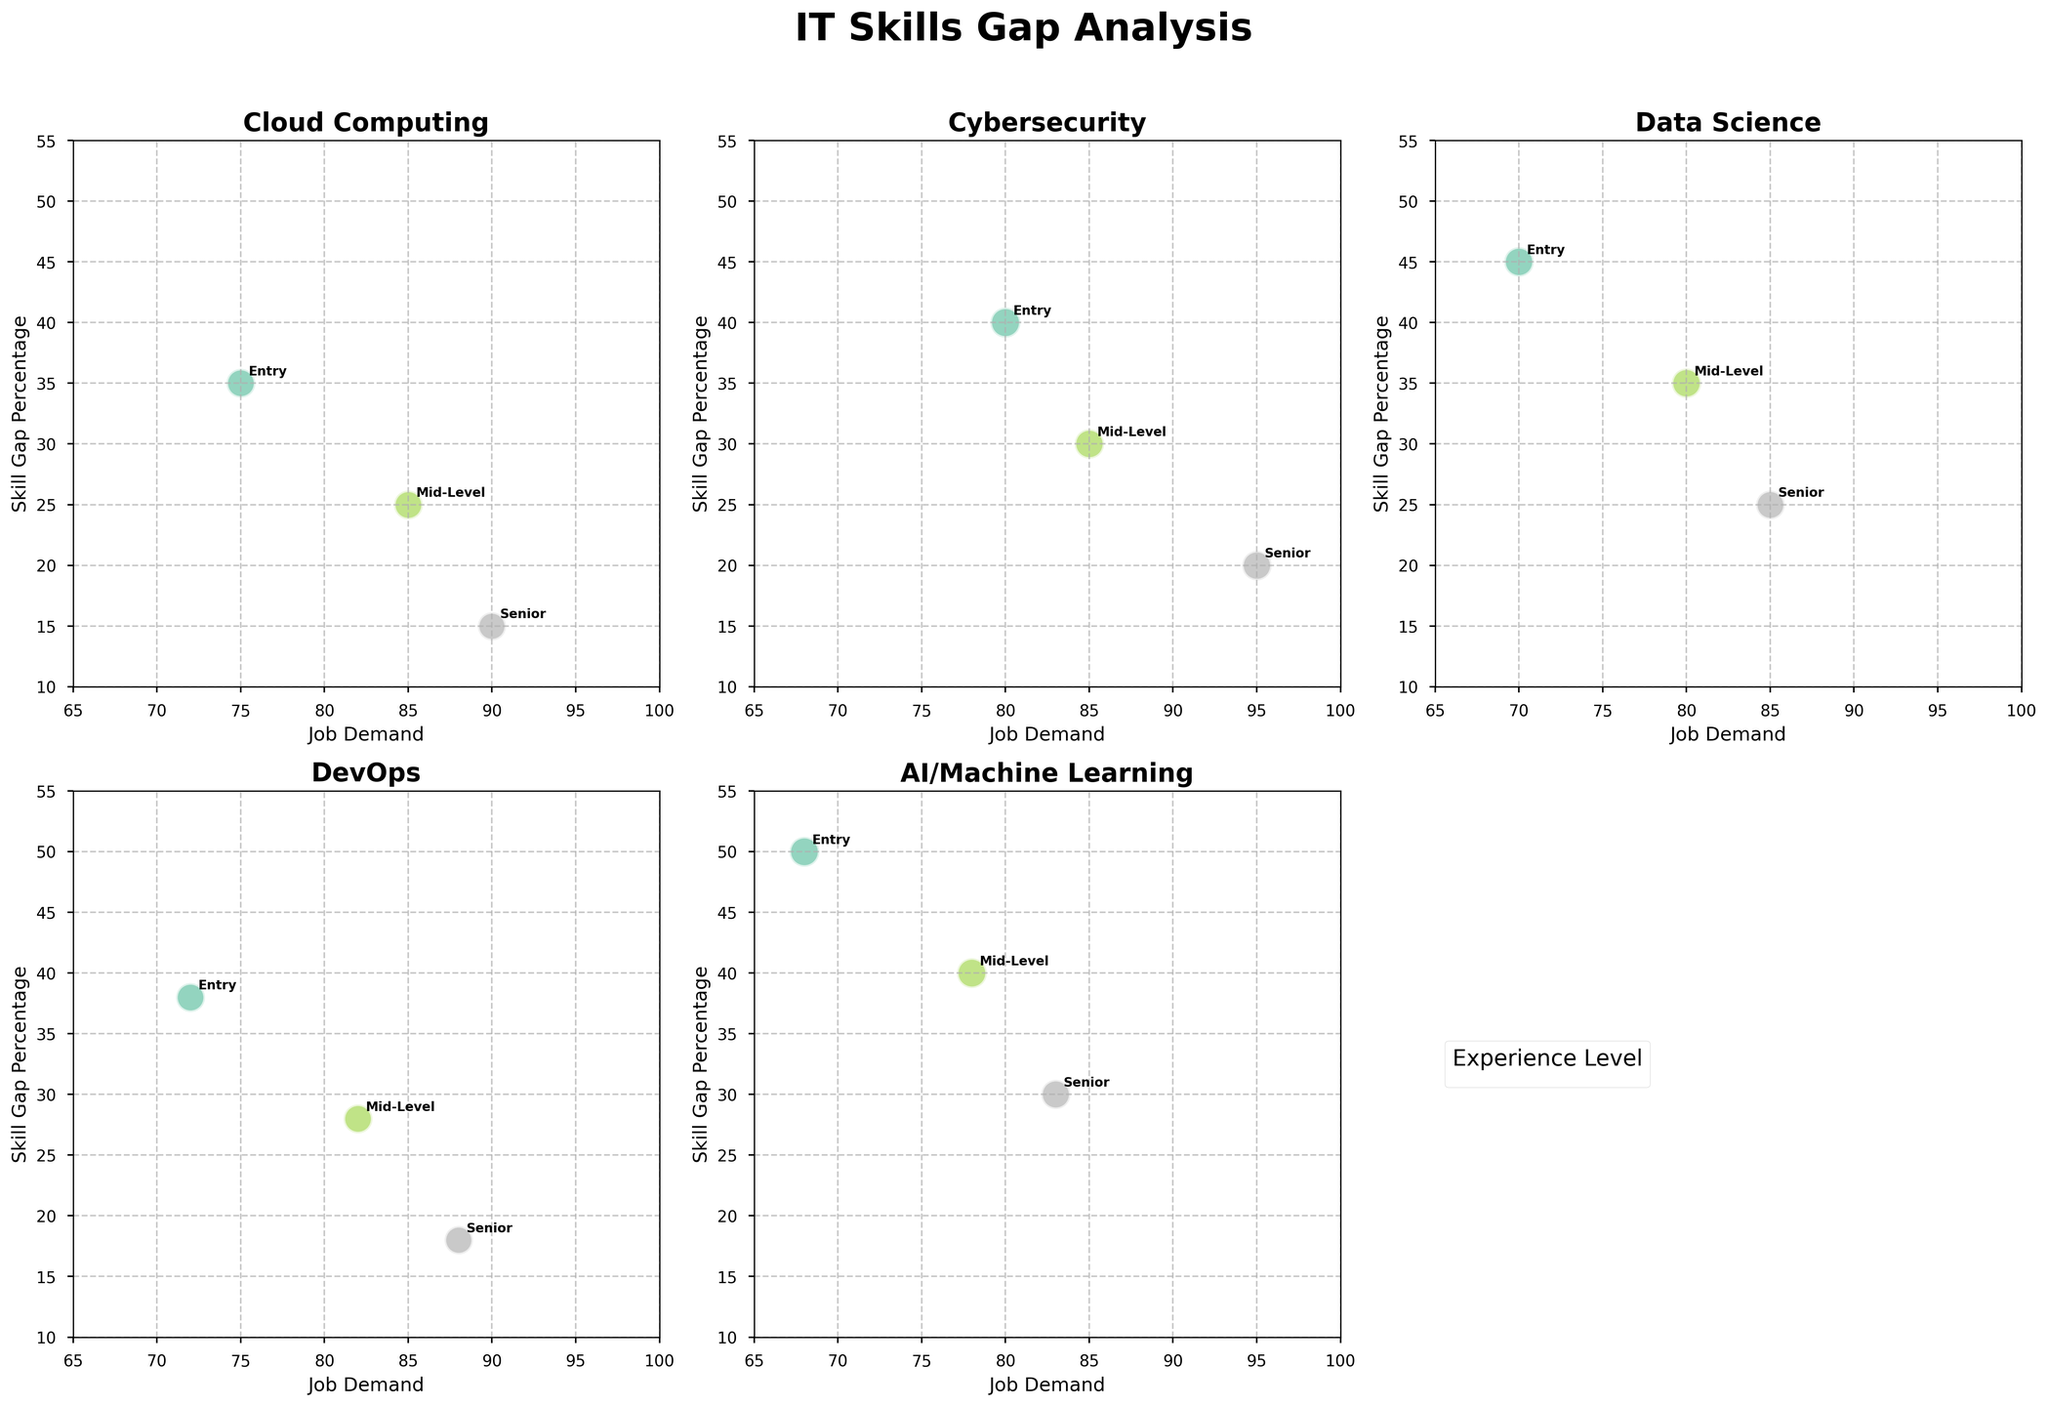What's the title of the figure? At the top of the figure, the text "IT Skills Gap Analysis" is prominently displayed.
Answer: IT Skills Gap Analysis How many experience levels are there in the figure? There are annotations and the legend in the figure that mention three experience levels: Entry, Mid-Level, and Senior.
Answer: Three Which specialization has the highest skill gap percentage for the entry-level experience? By looking at the y-axis (Skill Gap Percentage) and identifying the highest point for Entry-level under each specialization, the highest gap is under AI/Machine Learning.
Answer: AI/Machine Learning Compare the skill gap percentage for Mid-Level experience in Cloud Computing and DevOps. Which is higher? By observing the positions on the y-axis, the Mid-Level skill gap in Cloud Computing is at 25%, while for DevOps it is at 28%.
Answer: DevOps What is the trend between Job Demand and Skill Gap Percentage for Cybersecurity as experience levels increase? For Cybersecurity, as experience levels increase from Entry to Senior, the Job Demand increases (80 to 95) while the Skill Gap Percentage decreases (40% to 20%).
Answer: Job Demand increases, Skill Gap decreases Which specialization has the smallest job demand for Entry-level positions? Observing the x-axis (Job Demand) and looking for the smallest values among Entry-level positions, AI/Machine Learning has the smallest job demand at 68.
Answer: AI/Machine Learning Is the Entry-level experience gap in DevOps higher or lower than the Senior level gap in AI/Machine Learning? Comparing the y-axis positions, the Entry-level gap in DevOps is 38%, while the Senior-level gap in AI/Machine Learning is 30%.
Answer: Higher What is the general pattern in skill gap percentage as experience level increases across all specializations? Observing the y-axis across all subplots, a common trend is that the Skill Gap Percentage generally decreases as the experience level increases from Entry to Senior for each specialization.
Answer: Decreases In the Cloud Computing specialization, does the skill gap percentage for Mid-Level experience align closer to Entry or Senior levels? For Cloud Computing, the Mid-Level skill gap is at 25%, Entry is at 35%, and Senior is at 15%. The gap decreases more significantly from Entry to Mid-Level (10%) compared to from Mid-Level to Senior (10%).
Answer: Closer to Senior 